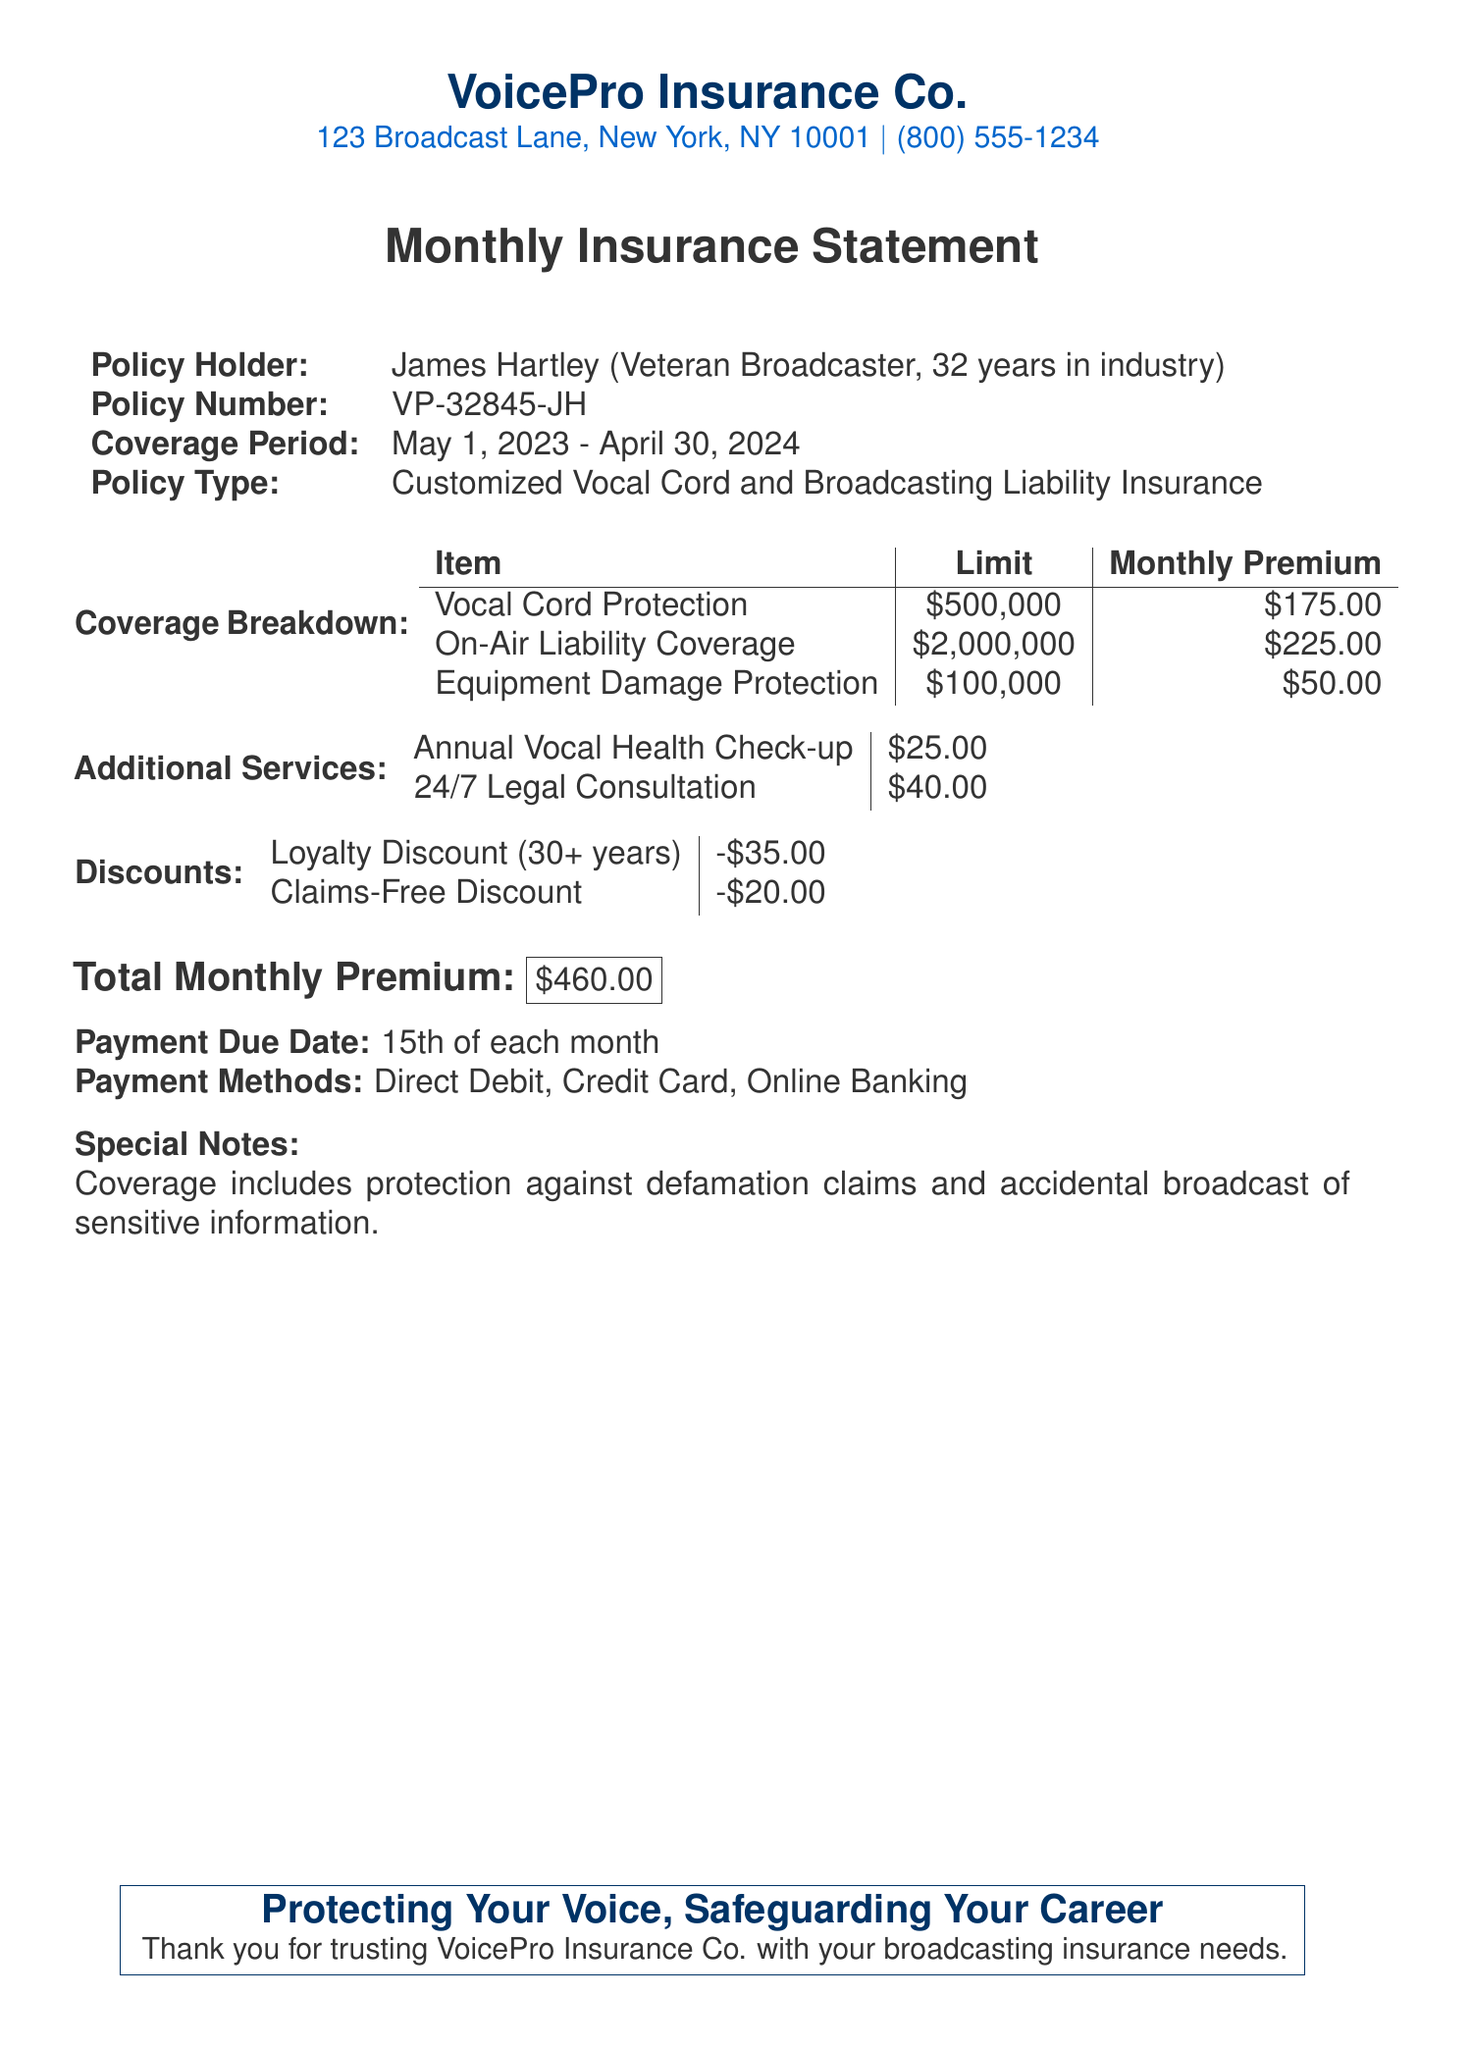What is the name of the insurance company? The document states the name of the insurance company as VoicePro Insurance Co.
Answer: VoicePro Insurance Co Who is the policy holder? The document identifies the policy holder as James Hartley, who is a veteran broadcaster with 32 years in the industry.
Answer: James Hartley What is the coverage period? The coverage period indicated in the document is from May 1, 2023 to April 30, 2024.
Answer: May 1, 2023 - April 30, 2024 What is the monthly premium for Vocal Cord Protection? The document specifies the monthly premium for Vocal Cord Protection as $175.00.
Answer: $175.00 What is the total monthly premium? The total monthly premium listed in the document is $460.00.
Answer: $460.00 What discounts are mentioned in the document? The document outlines a Loyalty Discount and Claims-Free Discount as the discounts provided.
Answer: Loyalty Discount, Claims-Free Discount How much is the Annual Vocal Health Check-up? The document states that the cost for the Annual Vocal Health Check-up is $25.00.
Answer: $25.00 What is the payment due date? The document specifies the payment due date as the 15th of each month.
Answer: 15th of each month What coverage is included against defamation? The document notes that coverage includes protection against defamation claims and accidental broadcast of sensitive information.
Answer: Protection against defamation claims 